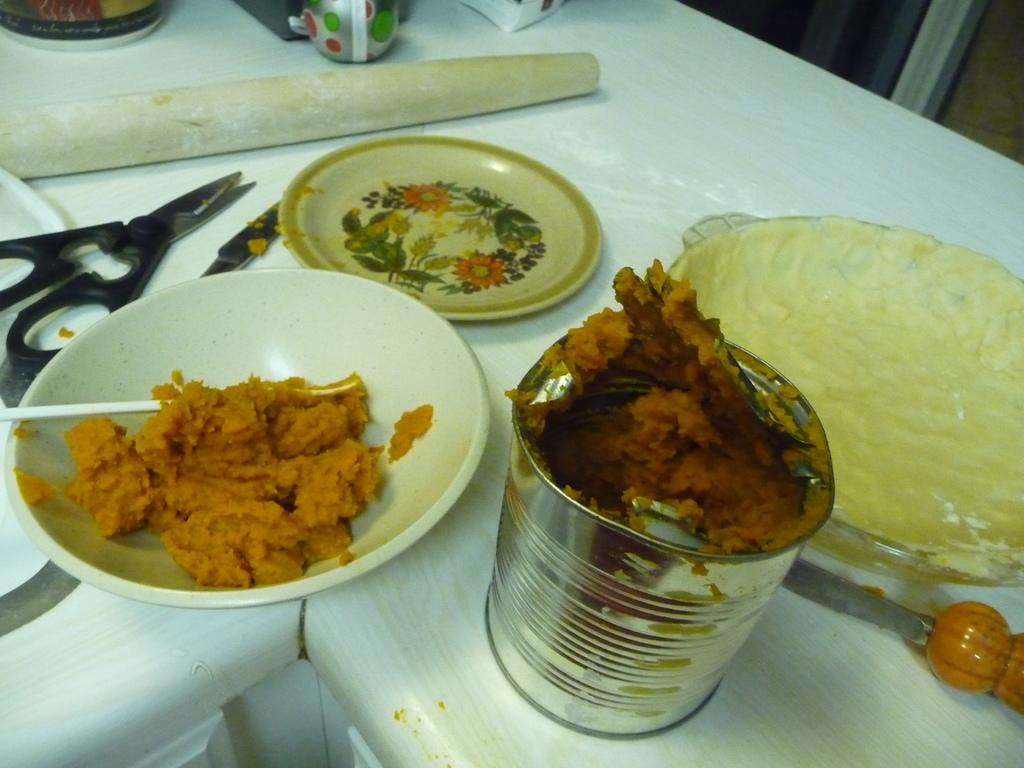What type of furniture is present in the image? There is a table in the image. What items can be seen on the table? There are plates, a bowl, a tin, dough, a knife, a pair of scissors, and food on the table. Can you describe the dough on the table? The dough is a substance that can be used to make various baked goods. What other objects are present on the table? There are other objects on the table, but their specific nature is not mentioned in the provided facts. How many ants are crawling on the table in the image? There is no mention of ants in the provided facts, so it cannot be determined from the image. 